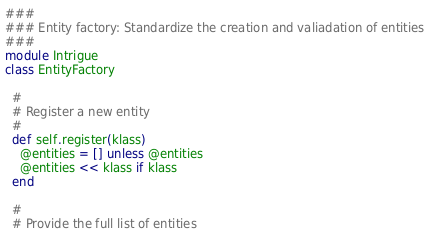Convert code to text. <code><loc_0><loc_0><loc_500><loc_500><_Ruby_>###
### Entity factory: Standardize the creation and valiadation of entities
###
module Intrigue
class EntityFactory

  #
  # Register a new entity
  #
  def self.register(klass)
    @entities = [] unless @entities
    @entities << klass if klass
  end

  #
  # Provide the full list of entities</code> 